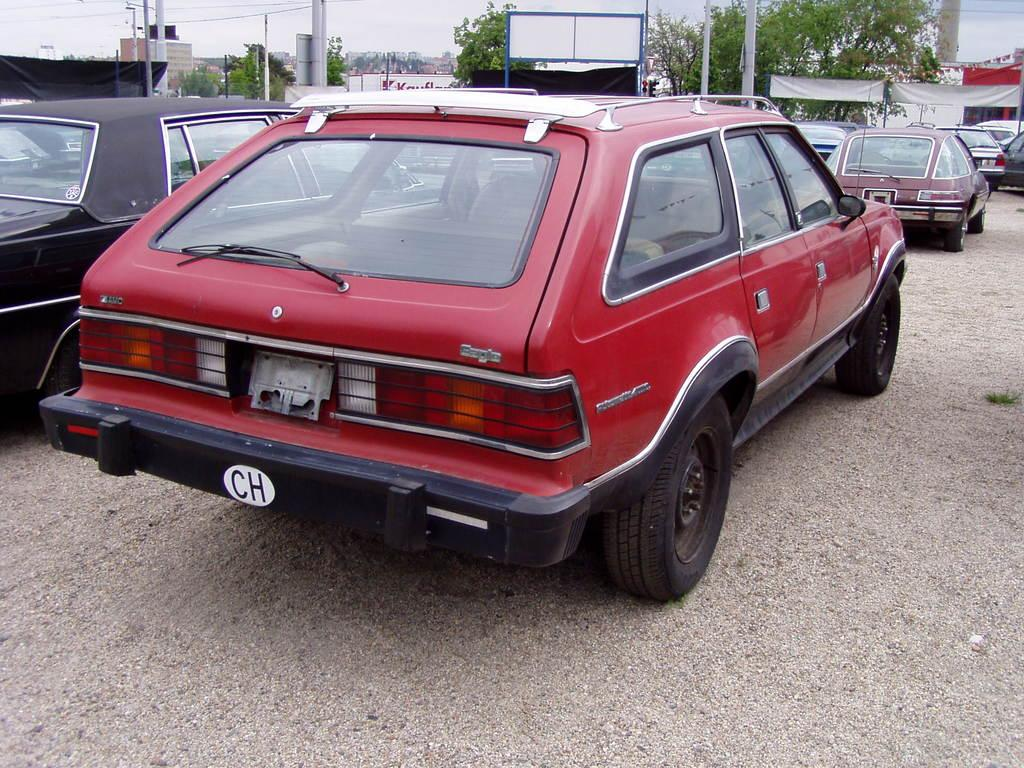What is the main subject in the center of the image? There is a car in the center of the image. What else can be seen in the background of the image? There are other cars, trees, poles, and posters in the background of the image. How many cars are visible in the image? There is one car in the center and at least one other car in the background, making a total of at least two cars visible. What type of structures are present in the background of the image? The poles and posters in the background suggest the presence of some form of infrastructure or signage. Can you describe the fight between the ants in the image? There are no ants present in the image, so there is no fight to describe. 